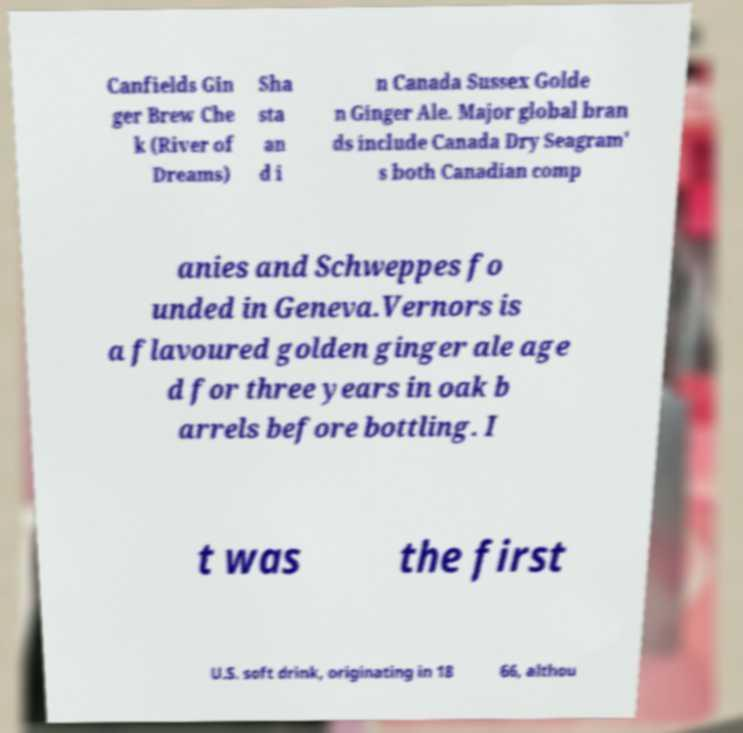Please read and relay the text visible in this image. What does it say? Canfields Gin ger Brew Che k (River of Dreams) Sha sta an d i n Canada Sussex Golde n Ginger Ale. Major global bran ds include Canada Dry Seagram' s both Canadian comp anies and Schweppes fo unded in Geneva.Vernors is a flavoured golden ginger ale age d for three years in oak b arrels before bottling. I t was the first U.S. soft drink, originating in 18 66, althou 